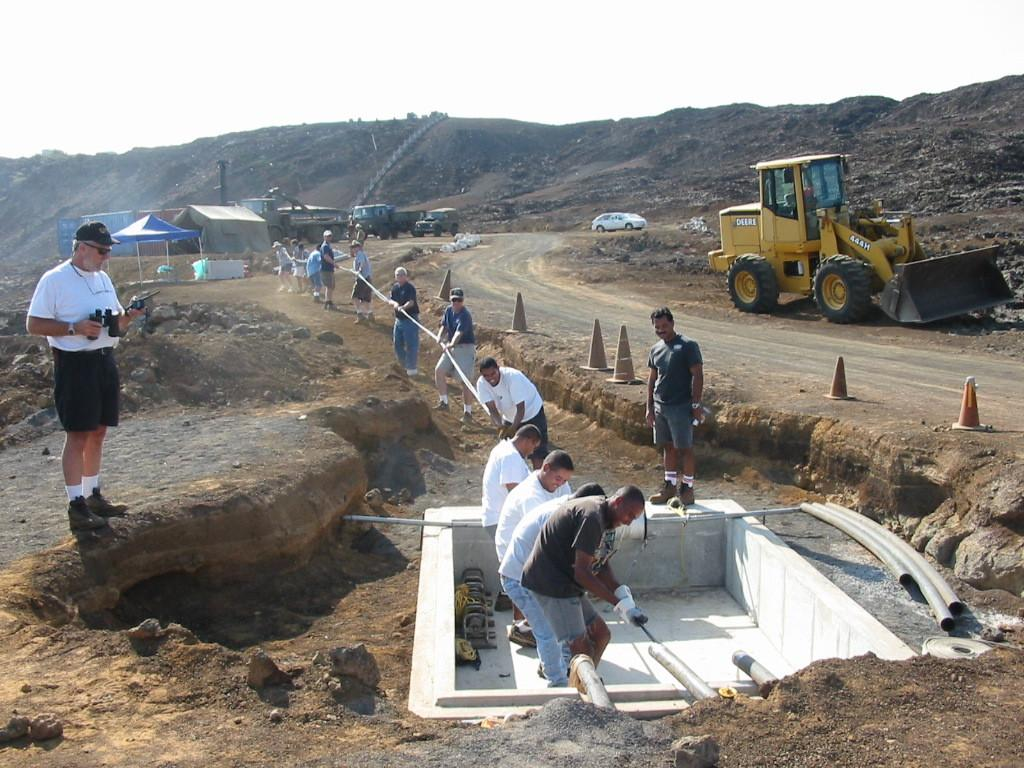What is happening on the ground in the image? There are people on the ground in the image. What objects are present to guide or control traffic? Traffic cones are present in the image. What types of vehicles can be seen in the image? Vehicles are visible in the image. What temporary structures are present in the image? Tents are in the image. What type of construction-related objects are visible in the image? Pipes are present in the image. What type of natural material is visible in the image? Stones are visible in the image. What is visible in the background of the image? The sky is visible in the background of the image. What type of creature is flying in the sky in the image? There is no creature flying in the sky in the image; only the sky is visible in the background. What type of lunch is being served in the image? There is no lunch being served in the image; the focus is on people, traffic cones, vehicles, tents, pipes, stones, and the sky. 